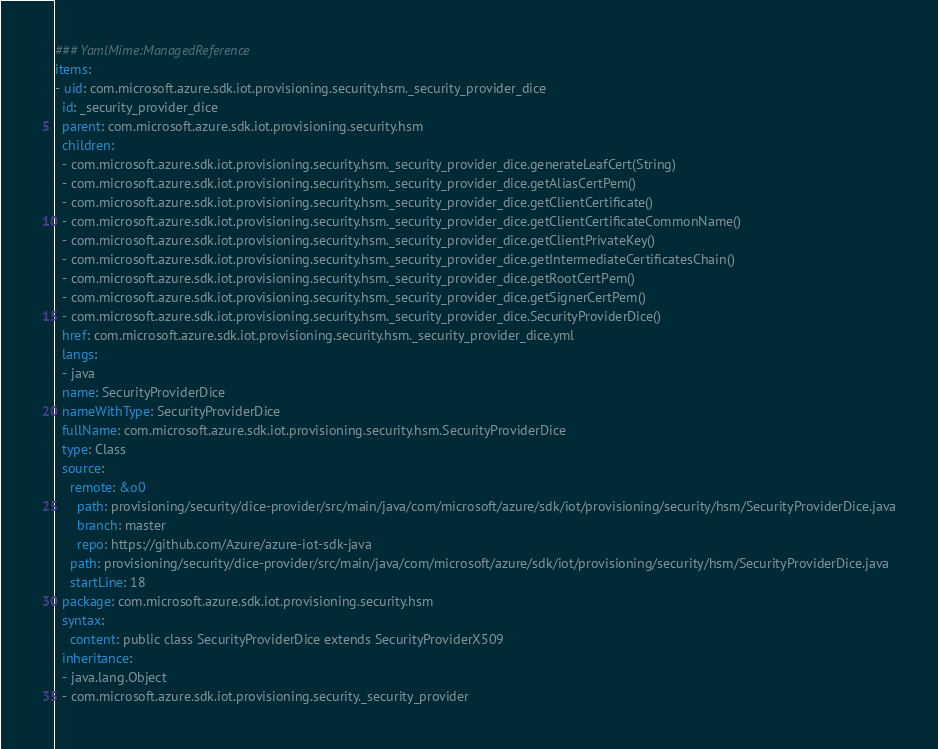<code> <loc_0><loc_0><loc_500><loc_500><_YAML_>### YamlMime:ManagedReference
items:
- uid: com.microsoft.azure.sdk.iot.provisioning.security.hsm._security_provider_dice
  id: _security_provider_dice
  parent: com.microsoft.azure.sdk.iot.provisioning.security.hsm
  children:
  - com.microsoft.azure.sdk.iot.provisioning.security.hsm._security_provider_dice.generateLeafCert(String)
  - com.microsoft.azure.sdk.iot.provisioning.security.hsm._security_provider_dice.getAliasCertPem()
  - com.microsoft.azure.sdk.iot.provisioning.security.hsm._security_provider_dice.getClientCertificate()
  - com.microsoft.azure.sdk.iot.provisioning.security.hsm._security_provider_dice.getClientCertificateCommonName()
  - com.microsoft.azure.sdk.iot.provisioning.security.hsm._security_provider_dice.getClientPrivateKey()
  - com.microsoft.azure.sdk.iot.provisioning.security.hsm._security_provider_dice.getIntermediateCertificatesChain()
  - com.microsoft.azure.sdk.iot.provisioning.security.hsm._security_provider_dice.getRootCertPem()
  - com.microsoft.azure.sdk.iot.provisioning.security.hsm._security_provider_dice.getSignerCertPem()
  - com.microsoft.azure.sdk.iot.provisioning.security.hsm._security_provider_dice.SecurityProviderDice()
  href: com.microsoft.azure.sdk.iot.provisioning.security.hsm._security_provider_dice.yml
  langs:
  - java
  name: SecurityProviderDice
  nameWithType: SecurityProviderDice
  fullName: com.microsoft.azure.sdk.iot.provisioning.security.hsm.SecurityProviderDice
  type: Class
  source:
    remote: &o0
      path: provisioning/security/dice-provider/src/main/java/com/microsoft/azure/sdk/iot/provisioning/security/hsm/SecurityProviderDice.java
      branch: master
      repo: https://github.com/Azure/azure-iot-sdk-java
    path: provisioning/security/dice-provider/src/main/java/com/microsoft/azure/sdk/iot/provisioning/security/hsm/SecurityProviderDice.java
    startLine: 18
  package: com.microsoft.azure.sdk.iot.provisioning.security.hsm
  syntax:
    content: public class SecurityProviderDice extends SecurityProviderX509
  inheritance:
  - java.lang.Object
  - com.microsoft.azure.sdk.iot.provisioning.security._security_provider</code> 